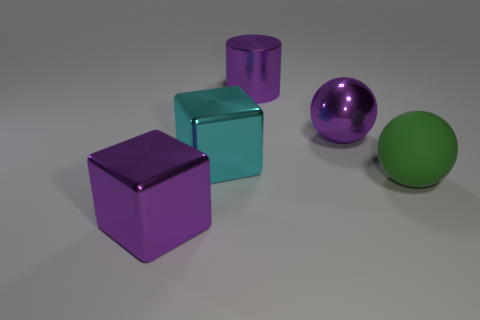Subtract all green spheres. How many spheres are left? 1 Subtract 1 cubes. How many cubes are left? 1 Add 1 big purple metal cylinders. How many objects exist? 6 Add 2 big blue matte things. How many big blue matte things exist? 2 Subtract 1 green balls. How many objects are left? 4 Subtract all blocks. How many objects are left? 3 Subtract all red spheres. Subtract all gray cylinders. How many spheres are left? 2 Subtract all red spheres. How many red cubes are left? 0 Subtract all large red blocks. Subtract all matte objects. How many objects are left? 4 Add 3 purple spheres. How many purple spheres are left? 4 